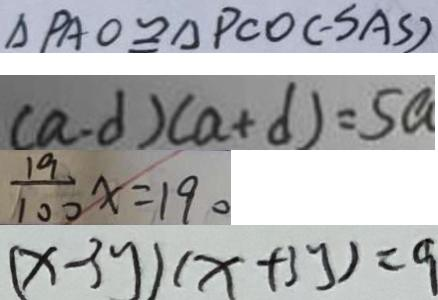<formula> <loc_0><loc_0><loc_500><loc_500>\Delta P A O \cong \Delta P C O ( - S A S ) 
 ( a - d ) ( a + d ) = 5 a 
 \frac { 1 9 } { 1 0 0 } x = 1 9 0 
 ( x - 3 y ) ( x + 3 y ) = 9</formula> 